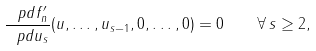Convert formula to latex. <formula><loc_0><loc_0><loc_500><loc_500>\frac { \ p d f ^ { \prime } _ { n } } { \ p d u _ { s } } ( u , \dots , u _ { s - 1 } , 0 , \dots , 0 ) = 0 \quad \forall \, s \geq 2 ,</formula> 